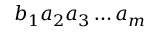<formula> <loc_0><loc_0><loc_500><loc_500>b _ { 1 } a _ { 2 } a _ { 3 } \dots a _ { m }</formula> 